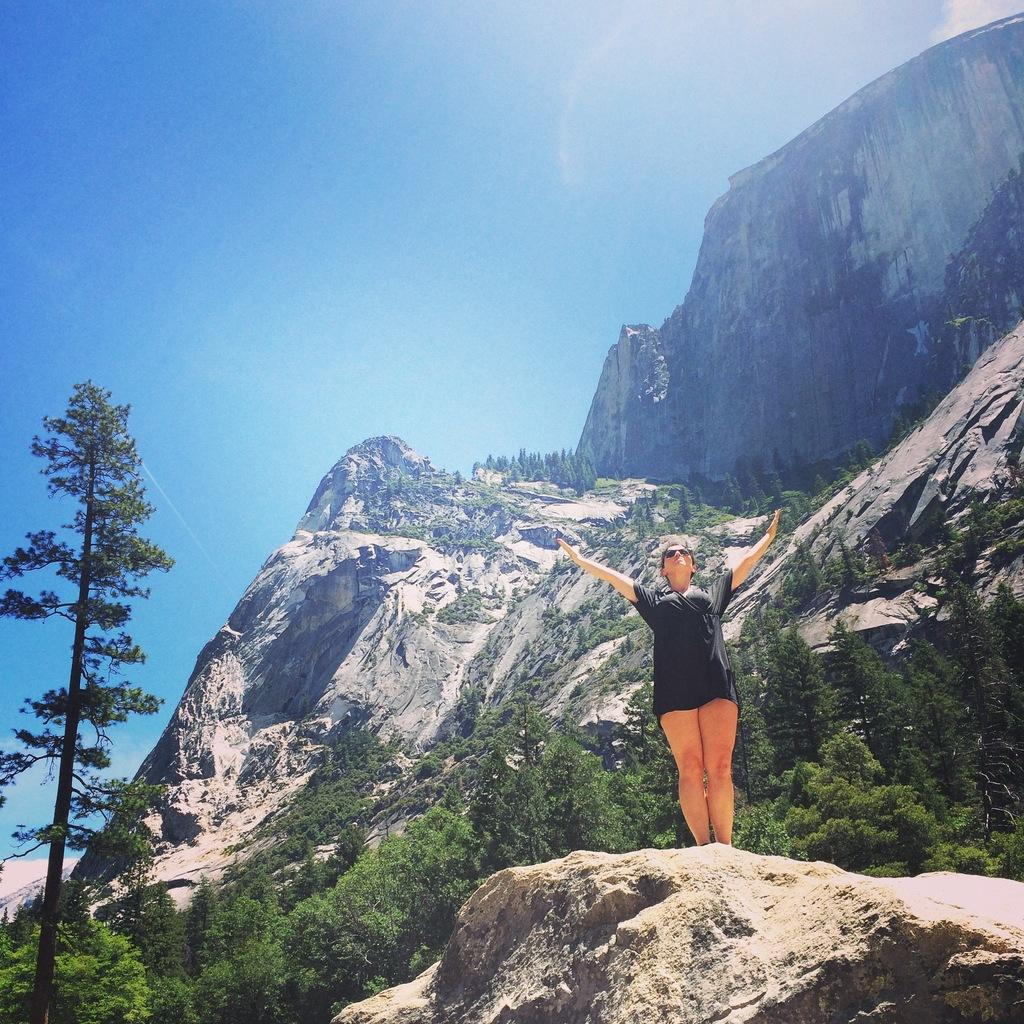Who is the main subject in the image? There is a woman in the image. What is the woman doing in the image? The woman is standing on a rock. What is the woman wearing in the image? The woman is wearing black clothes. What can be seen in the background of the image? There are mountains, trees, and clouds in the sky in the sky in the background of the image. Can you see a squirrel climbing the tree in the image? There is no squirrel present in the image; only the woman, the rock, the mountains, the trees, and the clouds are visible. 